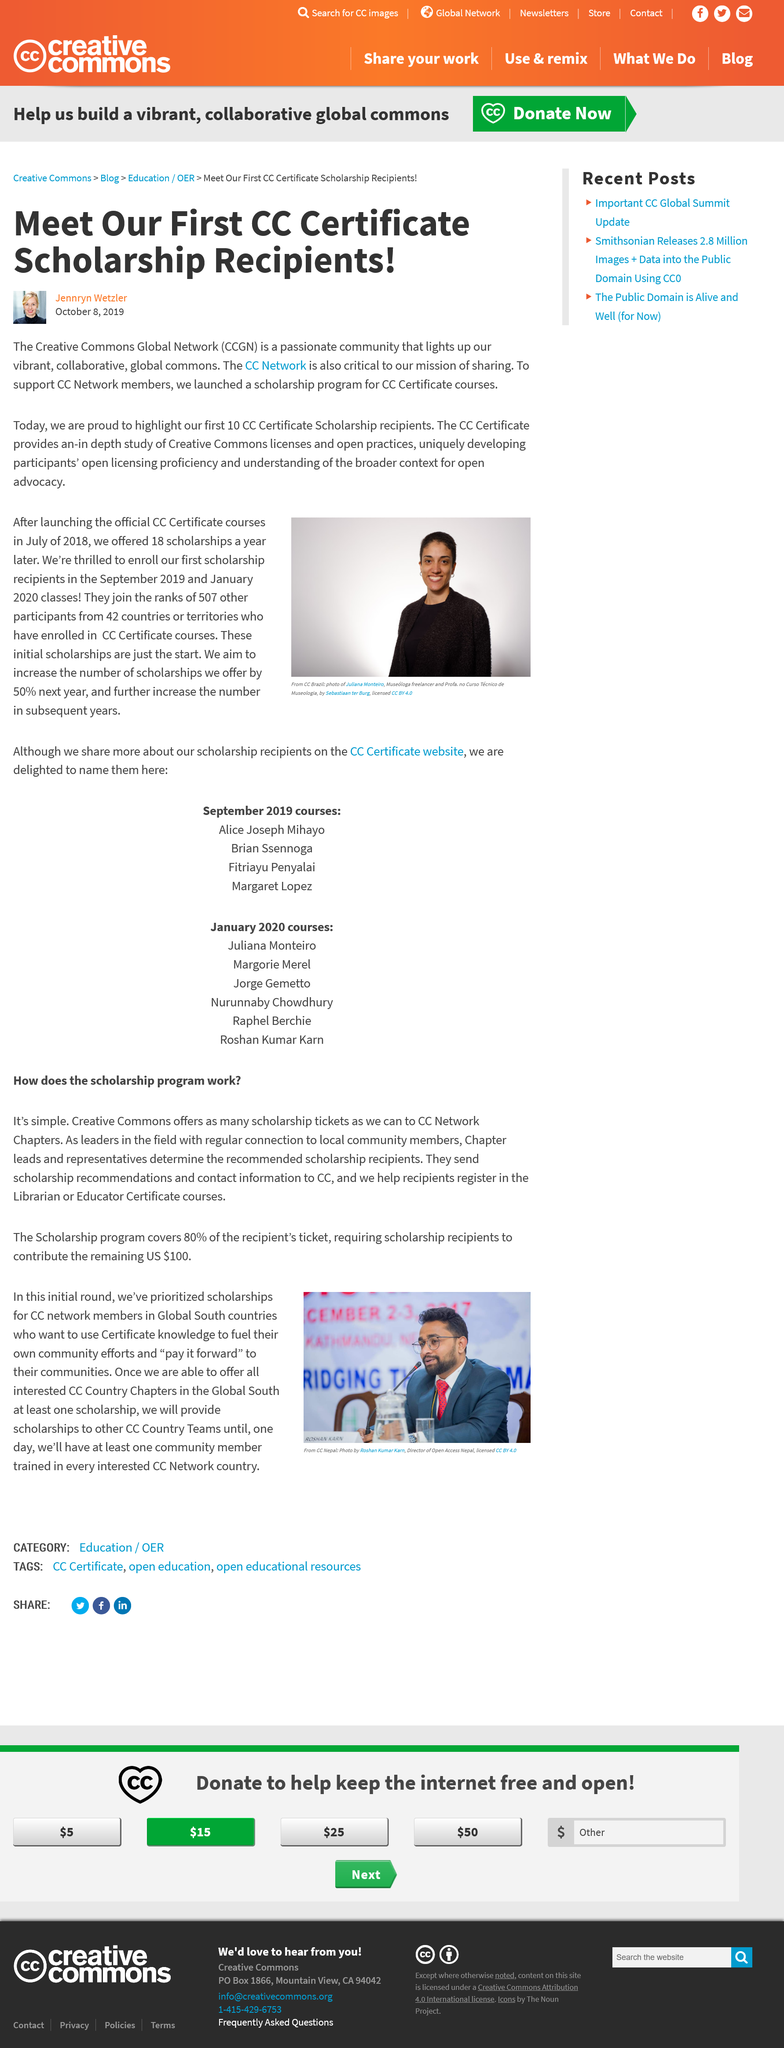Specify some key components in this picture. The CCGN launched the scholarship mentioned in the article to support CC Network members. The Climate and Clean Air Coalition has prioritized scholarships for members of its network in countries in the Global South. The article image features Roshan Karn, the Director of Open Access Nepal. The article highlights 10 scholarship recipients in total. After all Global South members have received a scholarship, the Church of Christ will provide scholarships to other Church of Christ country teams. 